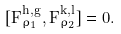Convert formula to latex. <formula><loc_0><loc_0><loc_500><loc_500>[ F _ { \rho _ { 1 } } ^ { h , g } , F _ { \rho _ { 2 } } ^ { k , l } ] = 0 .</formula> 